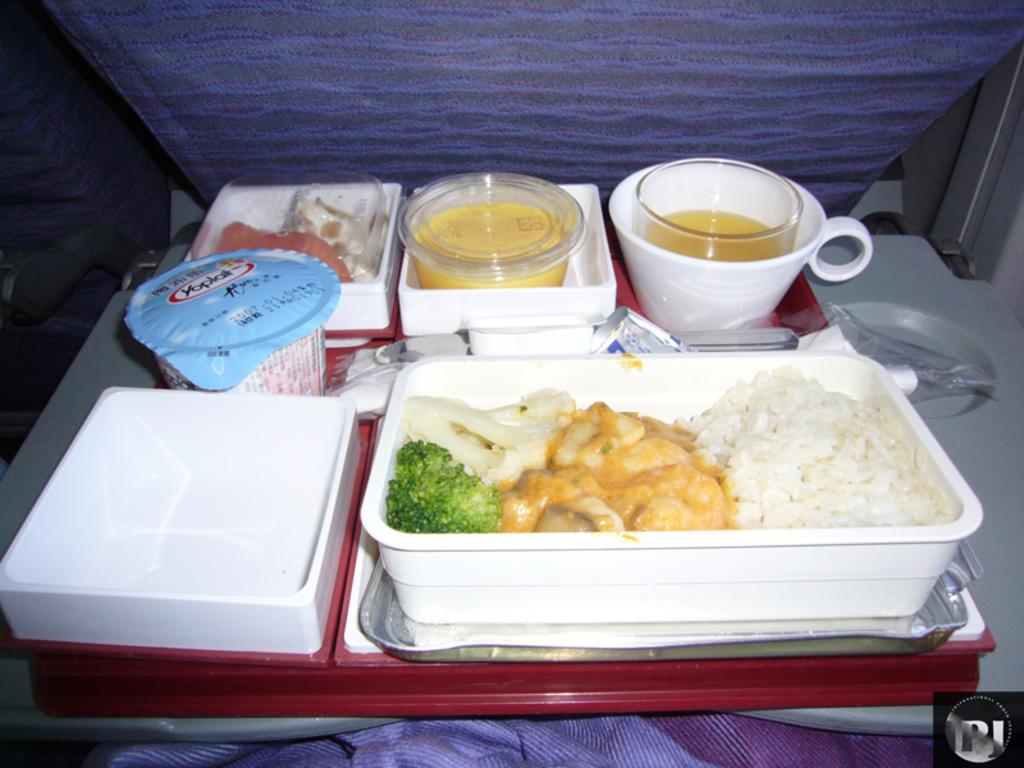What type of food is in the box in the image? The specific type of food in the box is not mentioned, but there is food in a box in the image. What other items can be seen in the image? There are bowls and a cup with juice in the image. Where are the items located in the image? The items are on a tray on a table stand. Can you see a sheep arguing with someone in the image? No, there is no sheep or argument present in the image. How many people are lifting the tray in the image? There is no indication of anyone lifting the tray in the image; it is on a table stand. 